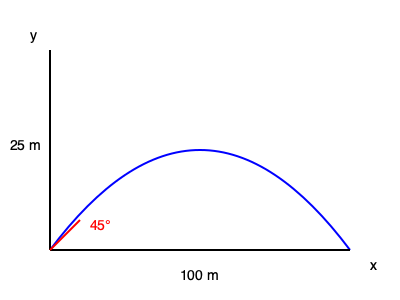In our latest episode's science segment, we discussed projectile motion. Imagine you're launching a water balloon at your co-host (all in good fun, of course). If you launch it at a 45° angle with an initial velocity of 20 m/s, and it reaches a maximum height of 25 meters, how far horizontally will it travel before hitting your unsuspecting co-host? Assume no air resistance and use $g = 10 \text{ m/s}^2$. Let's break this down step-by-step:

1) First, we need to find the time it takes for the water balloon to reach its maximum height. We can use the vertical component of velocity for this.

   Initial vertical velocity: $v_y = v_0 \sin \theta = 20 \sin 45° = 20 \cdot \frac{\sqrt{2}}{2} \approx 14.14 \text{ m/s}$

   At the highest point, vertical velocity is zero:
   $0 = v_y - gt$
   $t = \frac{v_y}{g} = \frac{14.14}{10} \approx 1.414 \text{ s}$

2) This is half the total time of flight. So the total time is:
   $T = 2t \approx 2.828 \text{ s}$

3) Now we can use the horizontal component of velocity to find the distance:
   
   Horizontal velocity: $v_x = v_0 \cos \theta = 20 \cos 45° = 20 \cdot \frac{\sqrt{2}}{2} \approx 14.14 \text{ m/s}$

   Distance = velocity × time
   $d = v_x \cdot T = 14.14 \cdot 2.828 \approx 40 \text{ m}$

4) We can verify this using the equation for the range of a projectile:
   $R = \frac{v_0^2 \sin 2\theta}{g} = \frac{20^2 \sin 90°}{10} = 40 \text{ m}$

Therefore, the water balloon will travel 40 meters horizontally before hitting your co-host.
Answer: 40 meters 